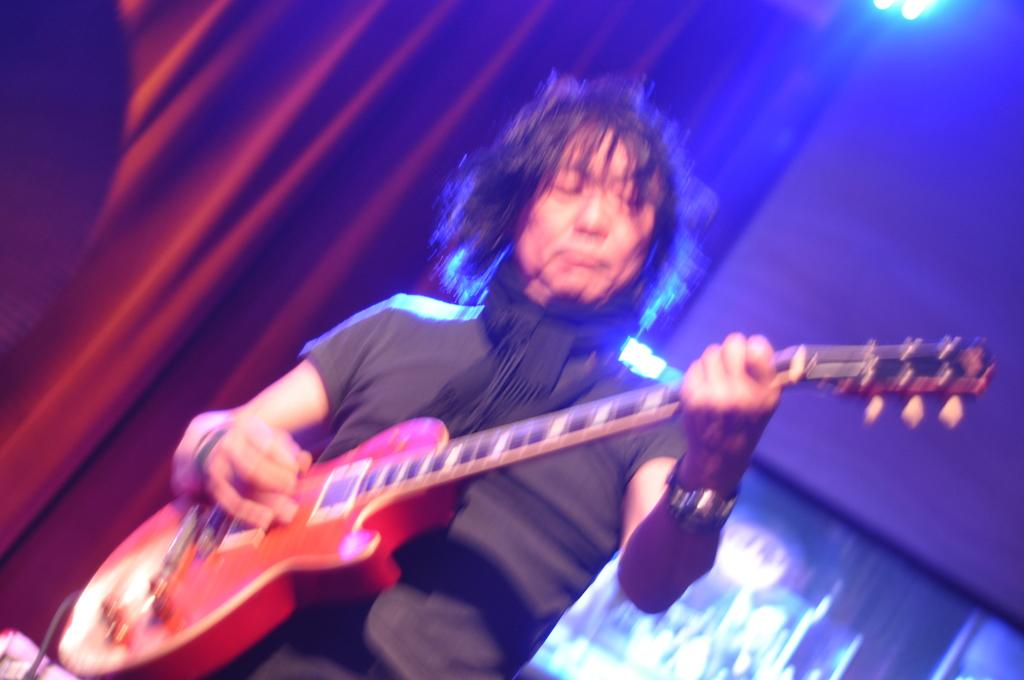What is the man in the image doing? The man is playing a guitar in the image. What is the man wearing on his upper body? The man is wearing a grey t-shirt. What is the man wearing around his neck? The man is wearing a black scarf. What can be seen in the background of the image? There is a curtain and a light in the background of the image. How many boys are eating food in the image? There are no boys or food present in the image; it features a man playing a guitar. Can you tell me what type of giraffe is visible in the image? There is no giraffe present in the image. 